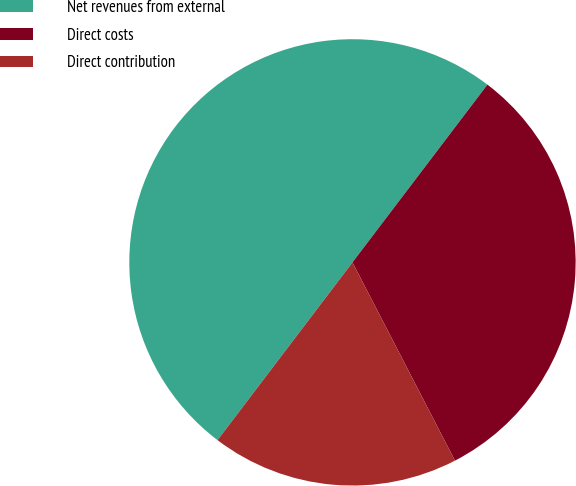Convert chart. <chart><loc_0><loc_0><loc_500><loc_500><pie_chart><fcel>Net revenues from external<fcel>Direct costs<fcel>Direct contribution<nl><fcel>50.0%<fcel>32.07%<fcel>17.93%<nl></chart> 